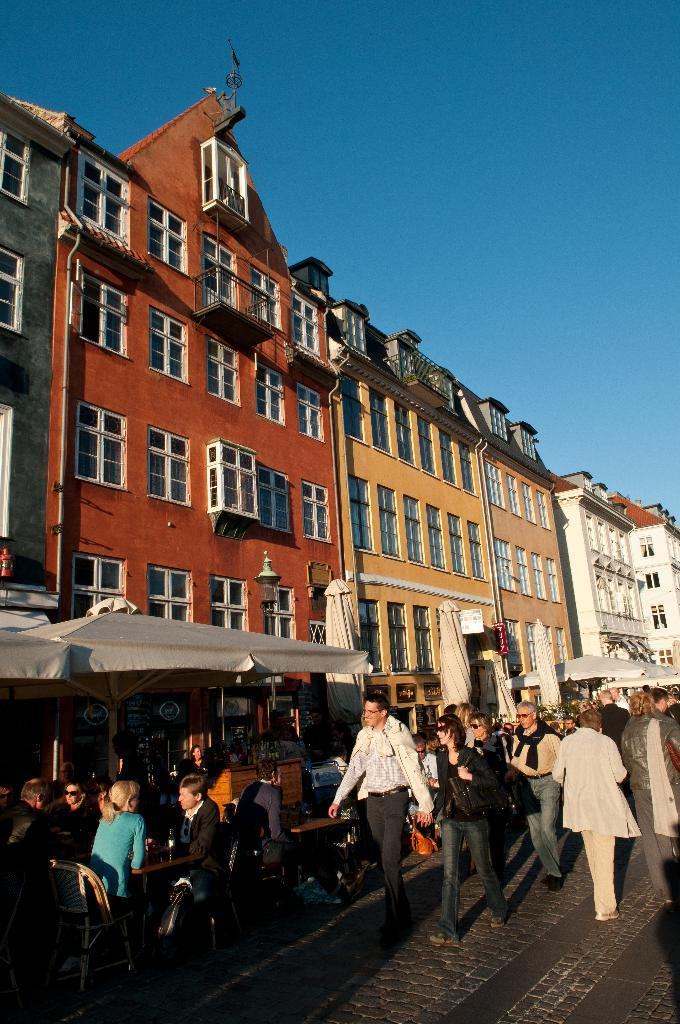What are the people in the image doing? There is a group of people standing and another group sitting on chairs in the image. What objects are being used by the people in the image? Umbrellas are visible in the image. What type of structures can be seen in the image? There are buildings in the image. What can be seen in the background of the image? The sky is visible in the background of the image. What type of boot is being exchanged between the people in the image? There is no boot being exchanged in the image; no boots are visible. 